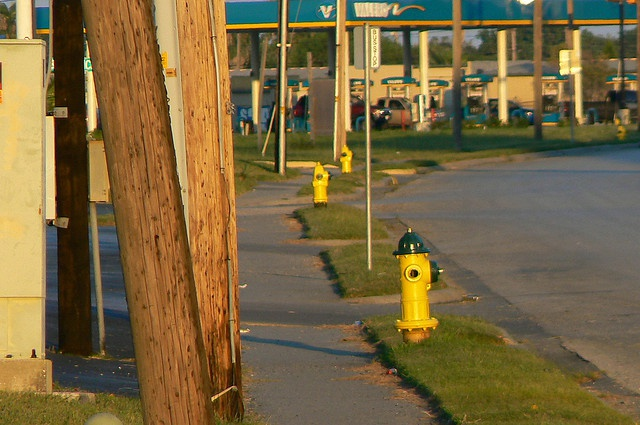Describe the objects in this image and their specific colors. I can see fire hydrant in darkgray, orange, gold, black, and olive tones, truck in darkgray, black, maroon, and gray tones, truck in darkgray, black, and gray tones, car in darkgray, gray, and black tones, and truck in darkgray, maroon, black, gray, and brown tones in this image. 